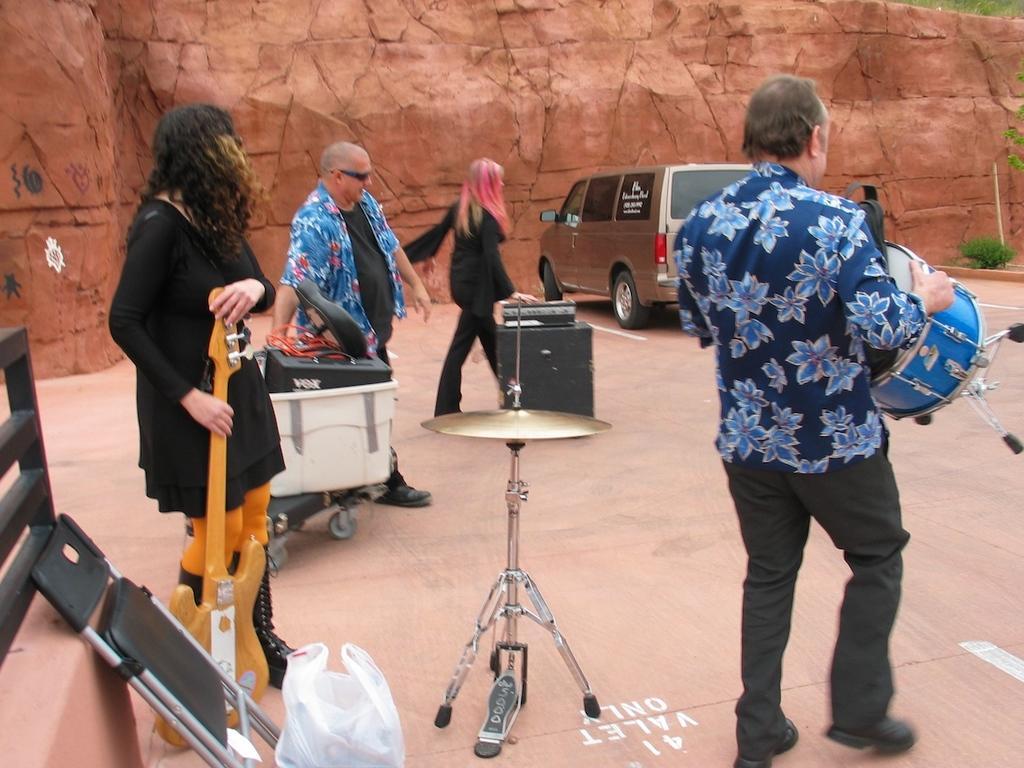Can you describe this image briefly? These persons are standing. This man is playing a drum. This woman is holding a guitar. Far there is a vehicle. This is a musical instrument. In this container there are things. 